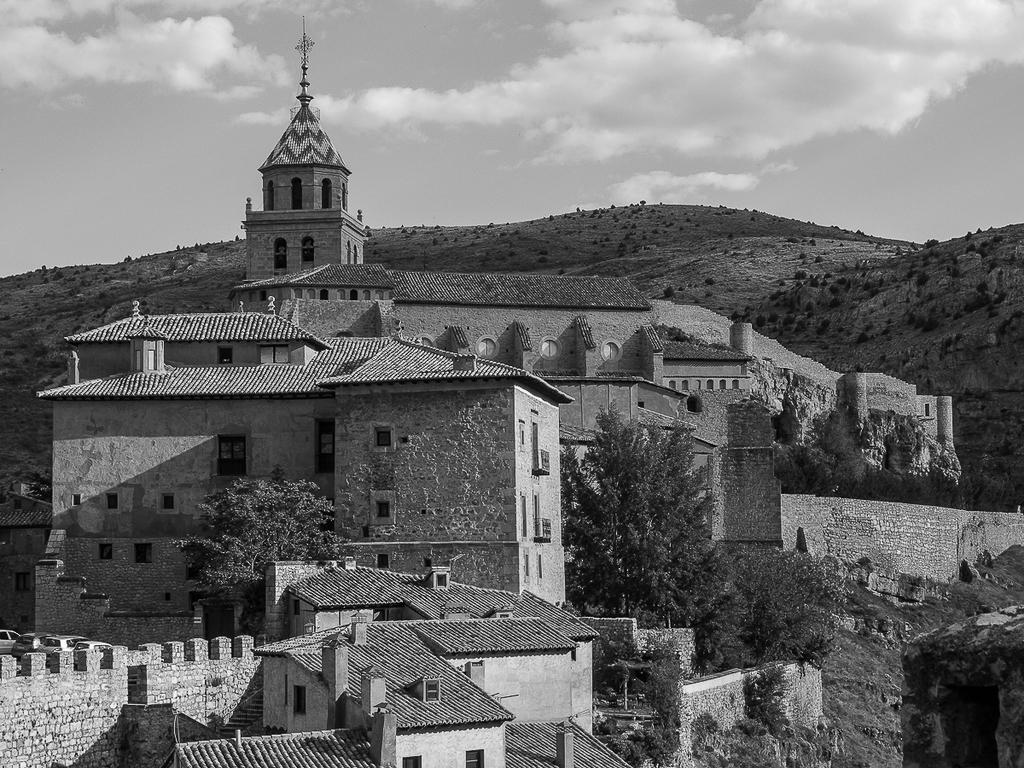In one or two sentences, can you explain what this image depicts? This is a black and white image. In this image, we can see buildings, plants, trees, rocks. At the top, we can see a sky. 